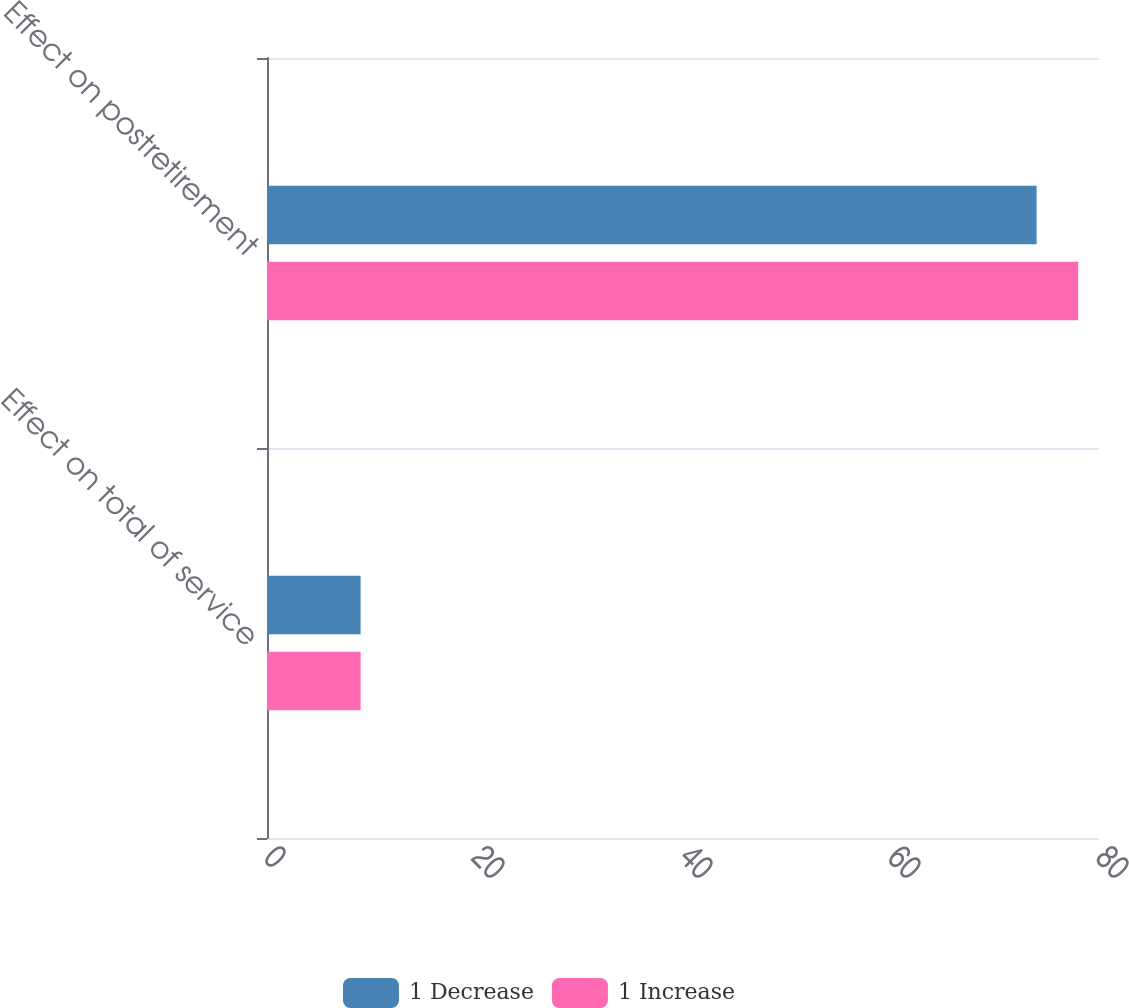Convert chart. <chart><loc_0><loc_0><loc_500><loc_500><stacked_bar_chart><ecel><fcel>Effect on total of service<fcel>Effect on postretirement<nl><fcel>1 Decrease<fcel>9<fcel>74<nl><fcel>1 Increase<fcel>9<fcel>78<nl></chart> 